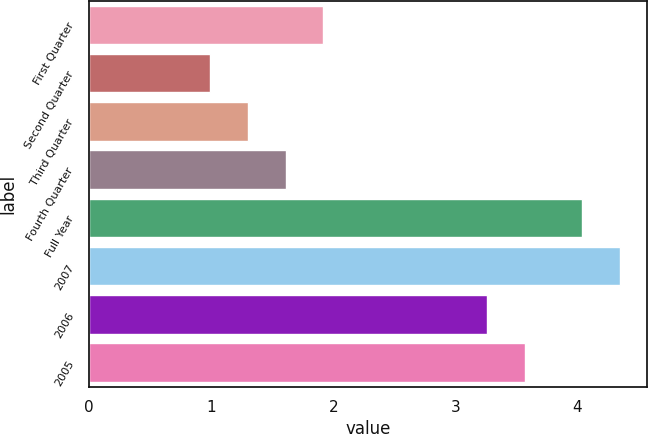Convert chart. <chart><loc_0><loc_0><loc_500><loc_500><bar_chart><fcel>First Quarter<fcel>Second Quarter<fcel>Third Quarter<fcel>Fourth Quarter<fcel>Full Year<fcel>2007<fcel>2006<fcel>2005<nl><fcel>1.92<fcel>0.99<fcel>1.3<fcel>1.61<fcel>4.04<fcel>4.35<fcel>3.26<fcel>3.57<nl></chart> 